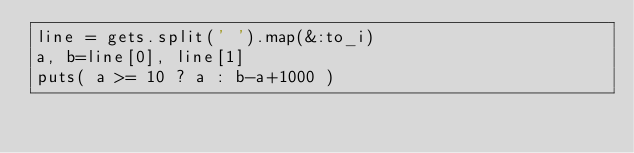Convert code to text. <code><loc_0><loc_0><loc_500><loc_500><_Ruby_>line = gets.split(' ').map(&:to_i)
a, b=line[0], line[1]
puts( a >= 10 ? a : b-a+1000 )</code> 